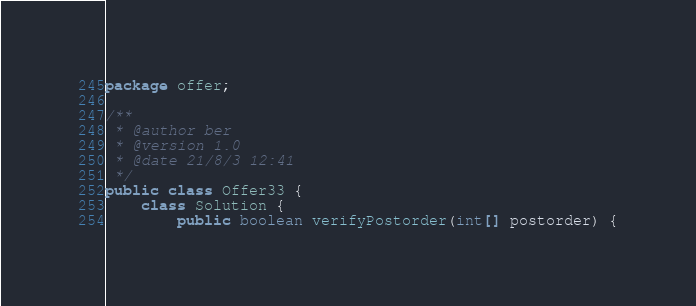<code> <loc_0><loc_0><loc_500><loc_500><_Java_>package offer;

/**
 * @author ber
 * @version 1.0
 * @date 21/8/3 12:41
 */
public class Offer33 {
    class Solution {
        public boolean verifyPostorder(int[] postorder) {</code> 